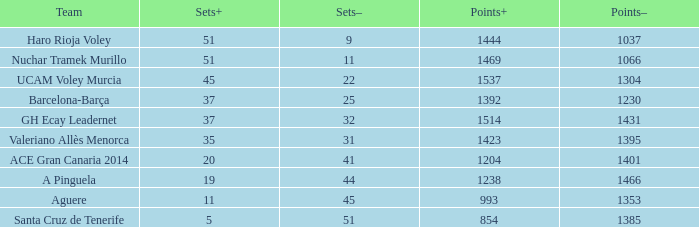What is the overall sum of points when the sets exceeds 51? 0.0. 